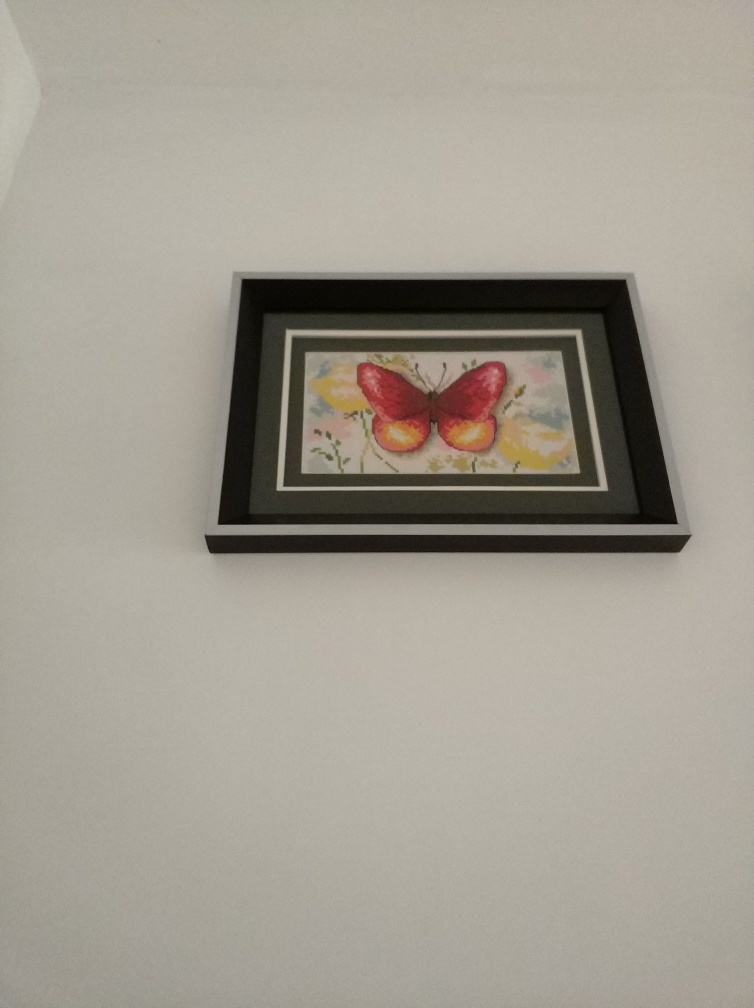What can you tell me about the composition of this artwork? The artwork features a striking butterfly with red and yellow wings, positioned at the center against a subtle and muted floral backdrop. Its central placement draws the viewer's attention, while the surrounding flora extends softly to the edges, balancing the composition nicely within the dark frame. 